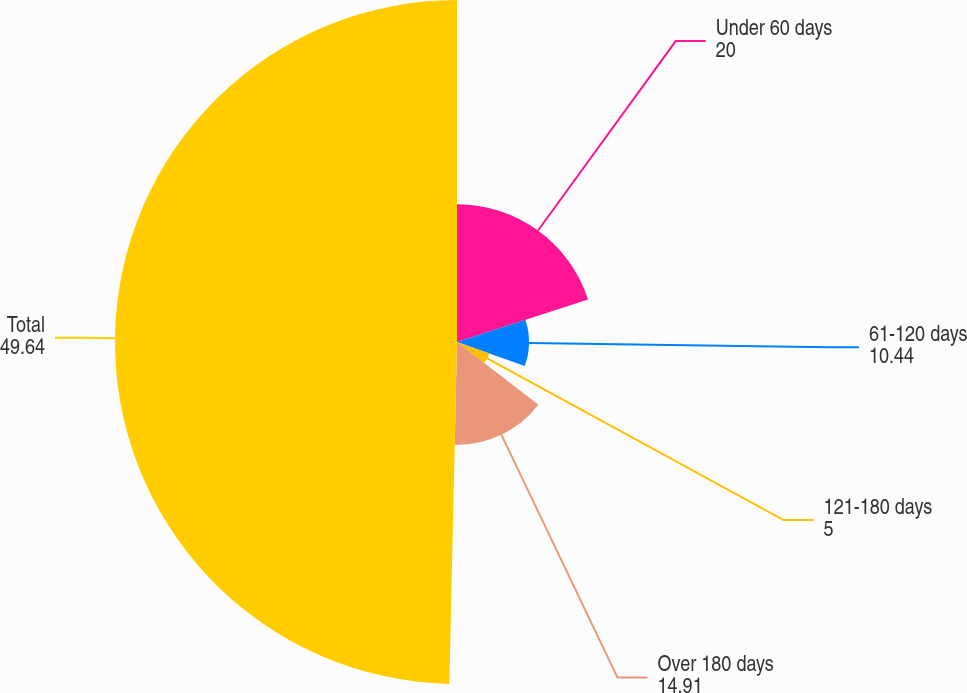Convert chart. <chart><loc_0><loc_0><loc_500><loc_500><pie_chart><fcel>Under 60 days<fcel>61-120 days<fcel>121-180 days<fcel>Over 180 days<fcel>Total<nl><fcel>20.0%<fcel>10.44%<fcel>5.0%<fcel>14.91%<fcel>49.64%<nl></chart> 